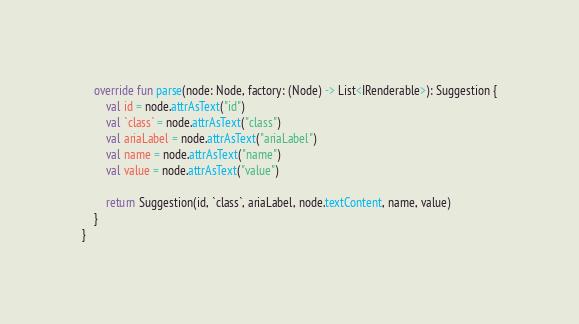<code> <loc_0><loc_0><loc_500><loc_500><_Kotlin_>    override fun parse(node: Node, factory: (Node) -> List<IRenderable>): Suggestion {
        val id = node.attrAsText("id")
        val `class` = node.attrAsText("class")
        val ariaLabel = node.attrAsText("ariaLabel")
        val name = node.attrAsText("name")
        val value = node.attrAsText("value")

        return Suggestion(id, `class`, ariaLabel, node.textContent, name, value)
    }
}</code> 